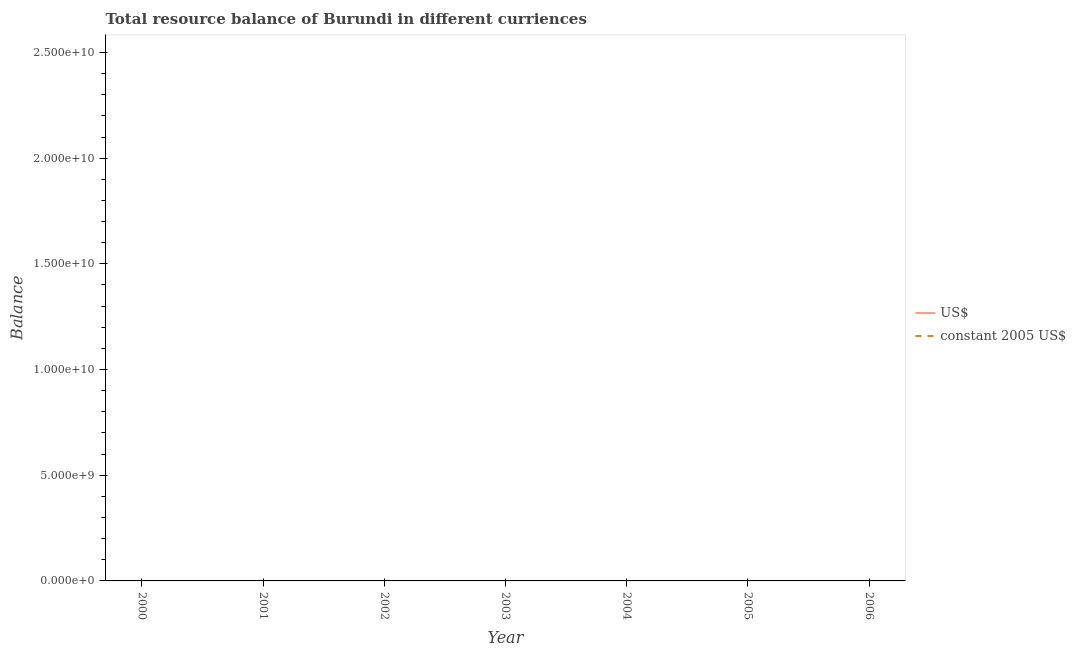What is the resource balance in constant us$ in 2001?
Give a very brief answer. 0. Is the resource balance in us$ strictly less than the resource balance in constant us$ over the years?
Your response must be concise. No. How many lines are there?
Give a very brief answer. 0. What is the difference between two consecutive major ticks on the Y-axis?
Your answer should be very brief. 5.00e+09. Are the values on the major ticks of Y-axis written in scientific E-notation?
Ensure brevity in your answer.  Yes. Where does the legend appear in the graph?
Make the answer very short. Center right. How are the legend labels stacked?
Make the answer very short. Vertical. What is the title of the graph?
Provide a succinct answer. Total resource balance of Burundi in different curriences. What is the label or title of the X-axis?
Keep it short and to the point. Year. What is the label or title of the Y-axis?
Give a very brief answer. Balance. What is the Balance of US$ in 2000?
Your answer should be very brief. 0. What is the Balance of constant 2005 US$ in 2000?
Provide a succinct answer. 0. What is the Balance of US$ in 2002?
Make the answer very short. 0. What is the Balance in constant 2005 US$ in 2003?
Give a very brief answer. 0. What is the Balance of US$ in 2004?
Keep it short and to the point. 0. What is the Balance of constant 2005 US$ in 2004?
Your answer should be very brief. 0. What is the total Balance in US$ in the graph?
Offer a very short reply. 0. 